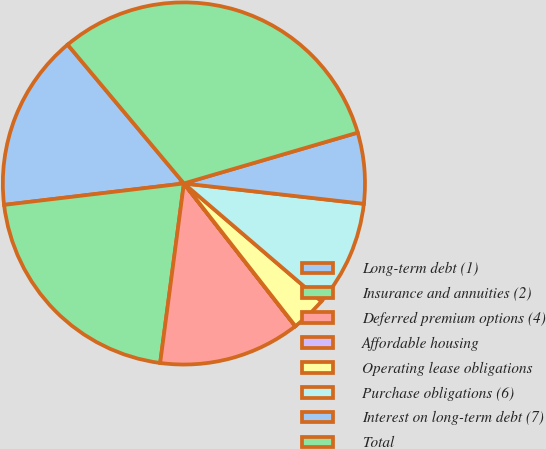Convert chart to OTSL. <chart><loc_0><loc_0><loc_500><loc_500><pie_chart><fcel>Long-term debt (1)<fcel>Insurance and annuities (2)<fcel>Deferred premium options (4)<fcel>Affordable housing<fcel>Operating lease obligations<fcel>Purchase obligations (6)<fcel>Interest on long-term debt (7)<fcel>Total<nl><fcel>15.79%<fcel>21.02%<fcel>12.64%<fcel>0.01%<fcel>3.17%<fcel>9.48%<fcel>6.32%<fcel>31.57%<nl></chart> 